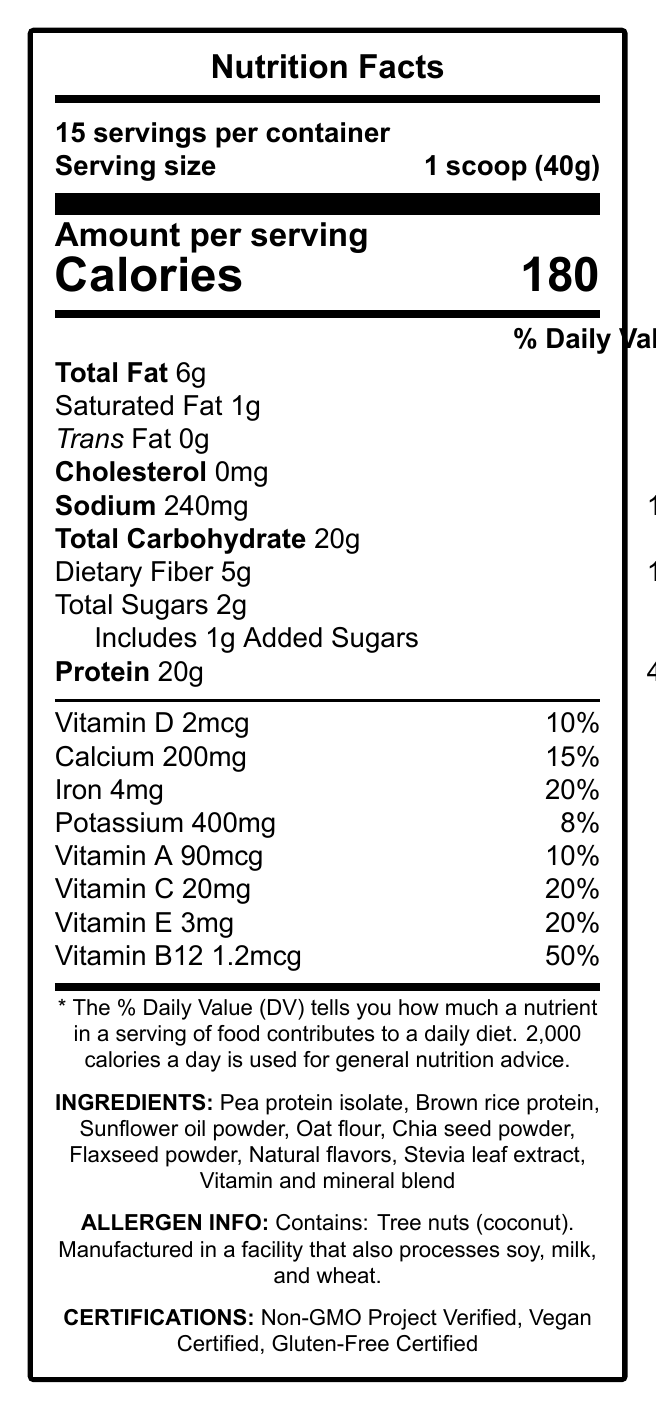what is the serving size? The document states that the serving size is 1 scoop, which weighs 40 grams.
Answer: 1 scoop (40g) how many calories are in one serving? The document specifies that each serving contains 180 calories.
Answer: 180 What is the daily value percentage of protein per serving? The document indicates that the Daily Value percentage for protein is 40% per serving.
Answer: 40% How much dietary fiber does one serving contain? According to the document, each serving contains 5 grams of dietary fiber.
Answer: 5g what certifications does the product hold? The certifications listed in the document are Non-GMO Project Verified, Vegan Certified, and Gluten-Free Certified.
Answer: Non-GMO Project Verified, Vegan Certified, Gluten-Free Certified which nutrient has the highest daily value percentage per serving? A. Vitamin D B. Vitamin B12 C. Iron D. Protein Vitamin B12 has the highest daily value percentage per serving at 50%.
Answer: B how many servings are in the container? A. 10 B. 12 C. 15 D. 20 The document specifies that there are 15 servings per container.
Answer: 15 does this product contain any allergens? Yes/No The document mentions that the product contains tree nuts (coconut) and is manufactured in a facility that also processes soy, milk, and wheat.
Answer: Yes summarize the main nutritional benefits of this product. The document highlights the product's balanced macronutrient content, significant contributions to daily vitamin and mineral intake, and certifications, facilitating weight management along with multiple health benefits.
Answer: The VitaBalance Plant-Based Meal Shake offers balanced macronutrients with 20g of protein, 6g of total fat, 5g of dietary fiber, and a low amount of added sugars. It provides a variety of vitamins and minerals, including high percentages of Vitamin B12, iron, and Vitamin C. It is also non-GMO, vegan, and gluten-free. what is the brand value emphasized in the product? The document underlines the brand values of plant-based nutrition, eco-friendly practices, and transparent sourcing.
Answer: Plant-based nutrition, Eco-friendly practices, Transparent sourcing how much iron does one serving provide and what is its daily value percentage? The document shows that one serving provides 4mg of iron, which is 20% of the daily value.
Answer: 4mg, 20% what ingredients are used in this product? The ingredients section lists all these components in the product.
Answer: Pea protein isolate, Brown rice protein, Sunflower oil powder, Oat flour, Chia seed powder, Flaxseed powder, Natural flavors, Stevia leaf extract, Vitamin and mineral blend what is the amount of sodium in one serving? The document indicates that there are 240mg of sodium in one serving.
Answer: 240mg what is the total carbohydrate content per serving and its daily value percentage? According to the document, each serving contains 20g of total carbohydrate, which is 7% of the daily value.
Answer: 20g, 7% what is the trans fat content in one serving? The document states that the trans fat content per serving is 0 grams.
Answer: 0g how many grams of added sugars are included in each serving? The document lists that there is 1 gram of added sugar in each serving.
Answer: 1g what sustainability information is provided about the product? The document mentions that the packaging is made from 100% post-consumer recycled materials.
Answer: Packaging made from 100% post-consumer recycled materials what is the preparation instruction for this product? The document provides these specific preparation instructions for using the product.
Answer: Mix 1 scoop (40g) with 8-10 oz of cold water or plant-based milk. Shake well and enjoy! does the document mention the balanced macronutrients and weight management benefits in the project management notes? The project management notes include a point about marketing materials highlighting the balanced macronutrients and weight management benefits.
Answer: Yes what is the storage instruction for this product? The document suggests storing the product in a cool, dry place and sealing it tightly after opening.
Answer: Store in a cool, dry place. Seal tightly after opening. what is the shelf life indicated for this product? The document indicates a shelf life of best if used within 2 years of the production date.
Answer: Best if used within 2 years of production date what is the vitamin D content per serving and its daily value percentage? The document indicates that each serving provides 2mcg of Vitamin D, which is 10% of the daily value.
Answer: 2mcg, 10% how much calcium does one serving provide? A. 100mg B. 200mg C. 300mg D. 400mg The document shows that one serving provides 200mg of calcium.
Answer: 200mg when is the FDA compliance review scheduled? The document does mention an FDA compliance review but does not provide a specific date for it.
Answer: Not enough information 